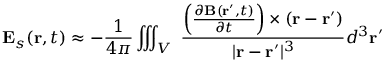Convert formula to latex. <formula><loc_0><loc_0><loc_500><loc_500>E _ { s } ( r , t ) \approx - { \frac { 1 } { 4 \pi } } \iiint _ { V } \ { \frac { \left ( { \frac { \partial B ( r ^ { \prime } , t ) } { \partial t } } \right ) \times \left ( r - r ^ { \prime } \right ) } { | r - r ^ { \prime } | ^ { 3 } } } d ^ { 3 } r ^ { \prime }</formula> 